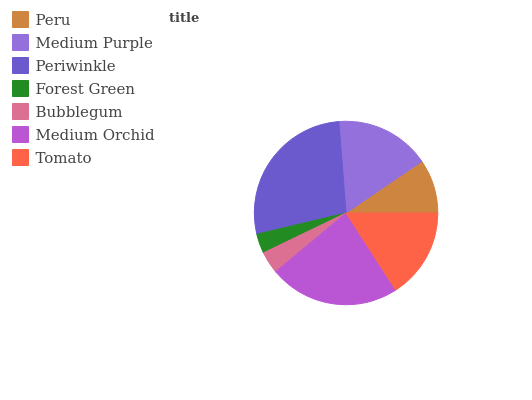Is Forest Green the minimum?
Answer yes or no. Yes. Is Periwinkle the maximum?
Answer yes or no. Yes. Is Medium Purple the minimum?
Answer yes or no. No. Is Medium Purple the maximum?
Answer yes or no. No. Is Medium Purple greater than Peru?
Answer yes or no. Yes. Is Peru less than Medium Purple?
Answer yes or no. Yes. Is Peru greater than Medium Purple?
Answer yes or no. No. Is Medium Purple less than Peru?
Answer yes or no. No. Is Tomato the high median?
Answer yes or no. Yes. Is Tomato the low median?
Answer yes or no. Yes. Is Forest Green the high median?
Answer yes or no. No. Is Medium Purple the low median?
Answer yes or no. No. 